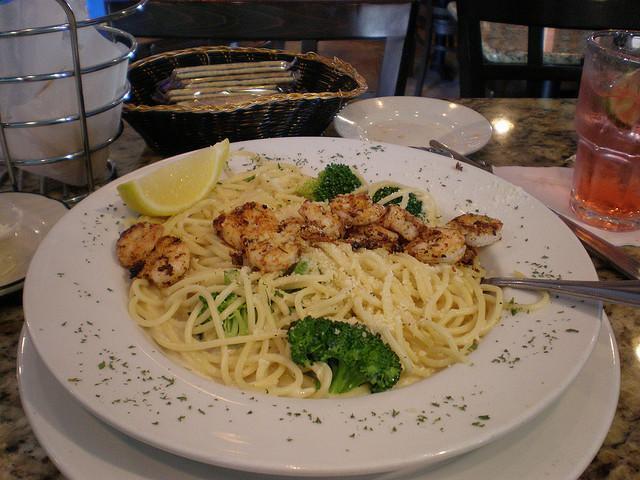What is in the spaghetti?
Select the accurate answer and provide explanation: 'Answer: answer
Rationale: rationale.'
Options: Meatball, shrimp, tomato sauce, egg. Answer: shrimp.
Rationale: The orange white and red coiled bits of meat with black spots from being cooked is identifiable as shrimp. 